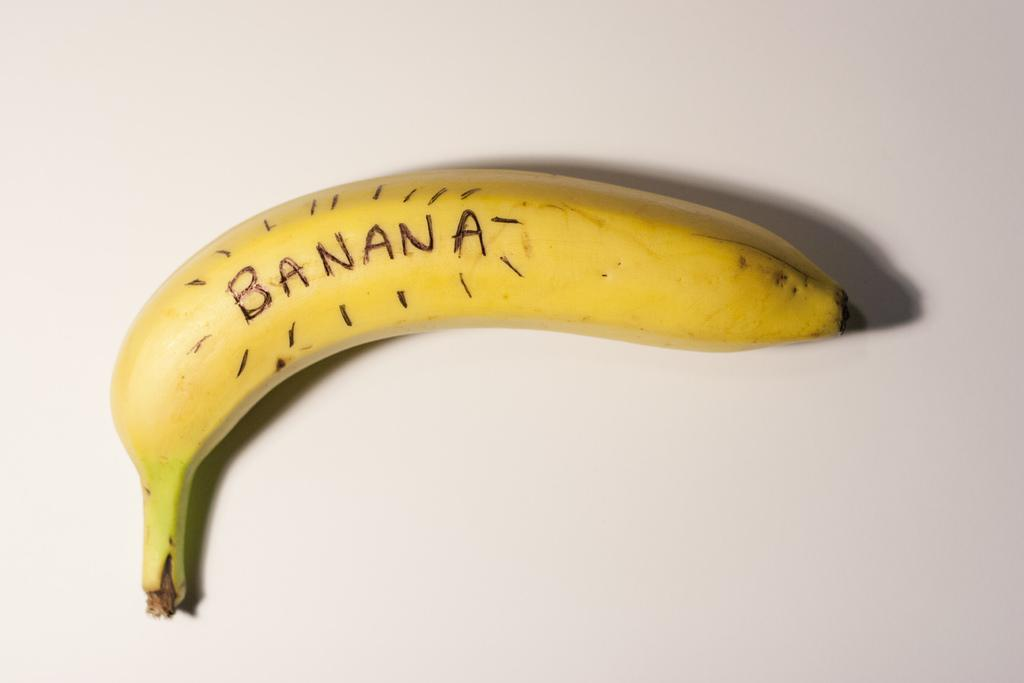What type of fruit is present in the image? There is a banana in the image. What is the color of the banana? The banana is yellow in color. On what surface is the banana placed? The banana is on a white surface. What advice is the banana giving in the image? The banana is not giving any advice in the image, as it is a fruit and not capable of providing advice. 